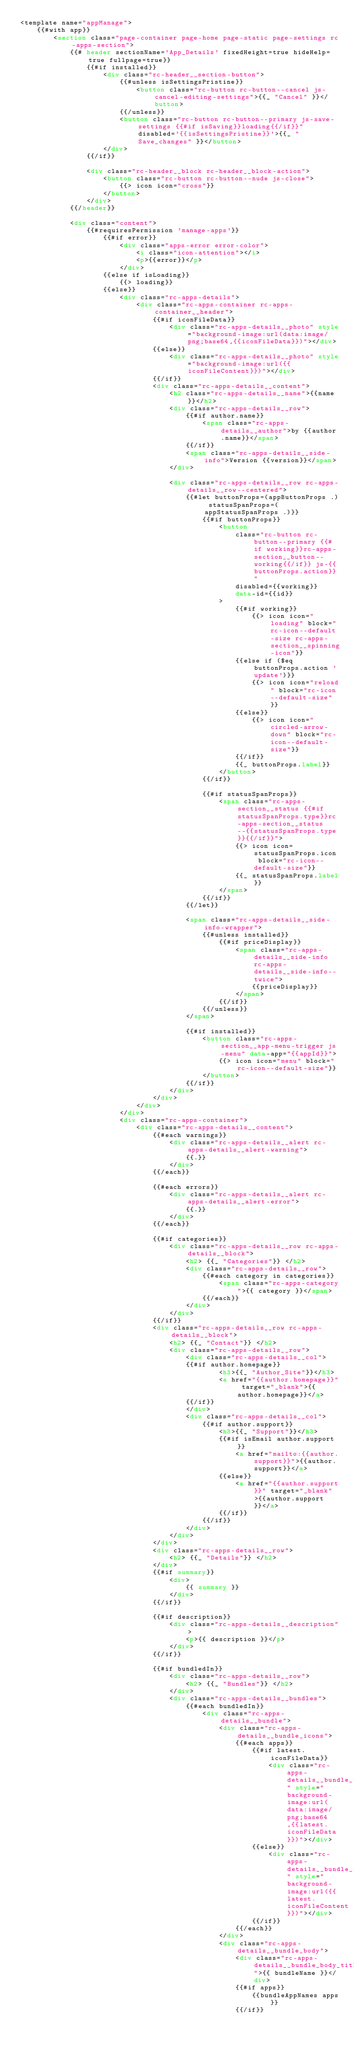<code> <loc_0><loc_0><loc_500><loc_500><_HTML_><template name="appManage">
	{{#with app}}
		<section class="page-container page-home page-static page-settings rc-apps-section">
			{{# header sectionName='App_Details' fixedHeight=true hideHelp=true fullpage=true}}
				{{#if installed}}
					<div class="rc-header__section-button">
						{{#unless isSettingsPristine}}
							<button class="rc-button rc-button--cancel js-cancel-editing-settings">{{_ "Cancel" }}</button>
						{{/unless}}
						<button class="rc-button rc-button--primary js-save-settings {{#if isSaving}}loading{{/if}}" disabled='{{isSettingsPristine}}'>{{_ "Save_changes" }}</button>
					</div>
				{{/if}}

				<div class="rc-header__block rc-header__block-action">
					<button class="rc-button rc-button--nude js-close">
						{{> icon icon="cross"}}
					</button>
				</div>
			{{/header}}

			<div class="content">
				{{#requiresPermission 'manage-apps'}}
					{{#if error}}
						<div class="apps-error error-color">
							<i class="icon-attention"></i>
							<p>{{error}}</p>
						</div>
					{{else if isLoading}}
						{{> loading}}
					{{else}}
						<div class="rc-apps-details">
							<div class="rc-apps-container rc-apps-container__header">
								{{#if iconFileData}}
									<div class="rc-apps-details__photo" style="background-image:url(data:image/png;base64,{{iconFileData}})"></div>
								{{else}}
									<div class="rc-apps-details__photo" style="background-image:url({{iconFileContent}})"></div>
								{{/if}}
								<div class="rc-apps-details__content">
									<h2 class="rc-apps-details__name">{{name}}</h2>
									<div class="rc-apps-details__row">
										{{#if author.name}}
											<span class="rc-apps-details__author">by {{author.name}}</span>
										{{/if}}
										<span class="rc-apps-details__side-info">Version {{version}}</span>
									</div>

									<div class="rc-apps-details__row rc-apps-details__row--centered">
										{{#let buttonProps=(appButtonProps .) statusSpanProps=(appStatusSpanProps .)}}
											{{#if buttonProps}}
												<button
													class="rc-button rc-button--primary {{#if working}}rc-apps-section__button--working{{/if}} js-{{buttonProps.action}}"
													disabled={{working}}
													data-id={{id}}
												>
													{{#if working}}
														{{> icon icon="loading" block="rc-icon--default-size rc-apps-section__spinning-icon"}}
													{{else if ($eq buttonProps.action 'update')}}
														{{> icon icon="reload" block="rc-icon--default-size"}}
													{{else}}
														{{> icon icon="circled-arrow-down" block="rc-icon--default-size"}}
													{{/if}}
													{{_ buttonProps.label}}
												</button>
											{{/if}}

											{{#if statusSpanProps}}
												<span class="rc-apps-section__status {{#if statusSpanProps.type}}rc-apps-section__status--{{statusSpanProps.type}}{{/if}}">
													{{> icon icon=statusSpanProps.icon block="rc-icon--default-size"}}
													{{_ statusSpanProps.label}}
												</span>
											{{/if}}
										{{/let}}

										<span class="rc-apps-details__side-info-wrapper">
											{{#unless installed}}
												{{#if priceDisplay}}
													<span class="rc-apps-details__side-info rc-apps-details__side-info--twice">
														{{priceDisplay}}
													</span>
												{{/if}}
											{{/unless}}
										</span>

										{{#if installed}}
											<button class="rc-apps-section__app-menu-trigger js-menu" data-app="{{appId}}">
												{{> icon icon="menu" block="rc-icon--default-size"}}
											</button>
										{{/if}}
									</div>
								</div>
							</div>
						</div>
						<div class="rc-apps-container">
							<div class="rc-apps-details__content">
								{{#each warnings}}
									<div class="rc-apps-details__alert rc-apps-details__alert-warning">
										{{.}}
									</div>
								{{/each}}

								{{#each errors}}
									<div class="rc-apps-details__alert rc-apps-details__alert-error">
										{{.}}
									</div>
								{{/each}}

								{{#if categories}}
									<div class="rc-apps-details__row rc-apps-details__block">
										<h2> {{_ "Categories"}} </h2>
										<div class="rc-apps-details__row">
											{{#each category in categories}}
												<span class="rc-apps-category">{{ category }}</span>
											{{/each}}
										</div>
									</div>
								{{/if}}
								<div class="rc-apps-details__row rc-apps-details__block">
									<h2> {{_ "Contact"}} </h2>
									<div class="rc-apps-details__row">
										<div class="rc-apps-details__col">
										{{#if author.homepage}}
												<h3>{{_ "Author_Site"}}</h3>
												<a href="{{author.homepage}}" target="_blank">{{author.homepage}}</a>
										{{/if}}
										</div>
										<div class="rc-apps-details__col">
											{{#if author.support}}
												<h3>{{_ "Support"}}</h3>
												{{#if isEmail author.support}}
													<a href="mailto:{{author.support}}">{{author.support}}</a>
												{{else}}
													<a href="{{author.support}}" target="_blank">{{author.support}}</a>
												{{/if}}
											{{/if}}
										</div>
									</div>
								</div>
								<div class="rc-apps-details__row">
									<h2> {{_ "Details"}} </h2>
								</div>
								{{#if summary}}
									<div>
										{{ summary }}
									</div>
								{{/if}}

								{{#if description}}
									<div class="rc-apps-details__description">
										<p>{{ description }}</p>
									</div>
								{{/if}}

								{{#if bundledIn}}
									<div class="rc-apps-details__row">
										<h2> {{_ "Bundles"}} </h2>
									</div>
									<div class="rc-apps-details__bundles">
										{{#each bundledIn}}
											<div class="rc-apps-details__bundle">
												<div class="rc-apps-details__bundle_icons">
													{{#each apps}}
														{{#if latest.iconFileData}}
															<div class="rc-apps-details__bundle_icon" style="background-image:url(data:image/png;base64,{{latest.iconFileData}})"></div>
														{{else}}
															<div class="rc-apps-details__bundle_icon" style="background-image:url({{latest.iconFileContent}})"></div>
														{{/if}}
													{{/each}}
												</div>
												<div class="rc-apps-details__bundle_body">
													<div class="rc-apps-details__bundle_body_title">{{ bundleName }}</div>
													{{#if apps}}
														{{bundleAppNames apps}}
													{{/if}}</code> 